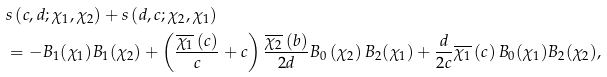Convert formula to latex. <formula><loc_0><loc_0><loc_500><loc_500>& s \left ( c , d ; \chi _ { 1 } , \chi _ { 2 } \right ) + s \left ( d , c ; \chi _ { 2 } , \chi _ { 1 } \right ) \\ & = - B _ { 1 } ( \chi _ { 1 } ) B _ { 1 } ( \chi _ { 2 } ) + \left ( \frac { \overline { \chi _ { 1 } } \left ( c \right ) } { c } + c \right ) \frac { \overline { \chi _ { 2 } } \left ( b \right ) } { 2 d } B _ { 0 } \left ( \chi _ { 2 } \right ) B _ { 2 } ( \chi _ { 1 } ) + \frac { d } { 2 c } \overline { \chi _ { 1 } } \left ( c \right ) B _ { 0 } ( \chi _ { 1 } ) B _ { 2 } ( \chi _ { 2 } ) ,</formula> 